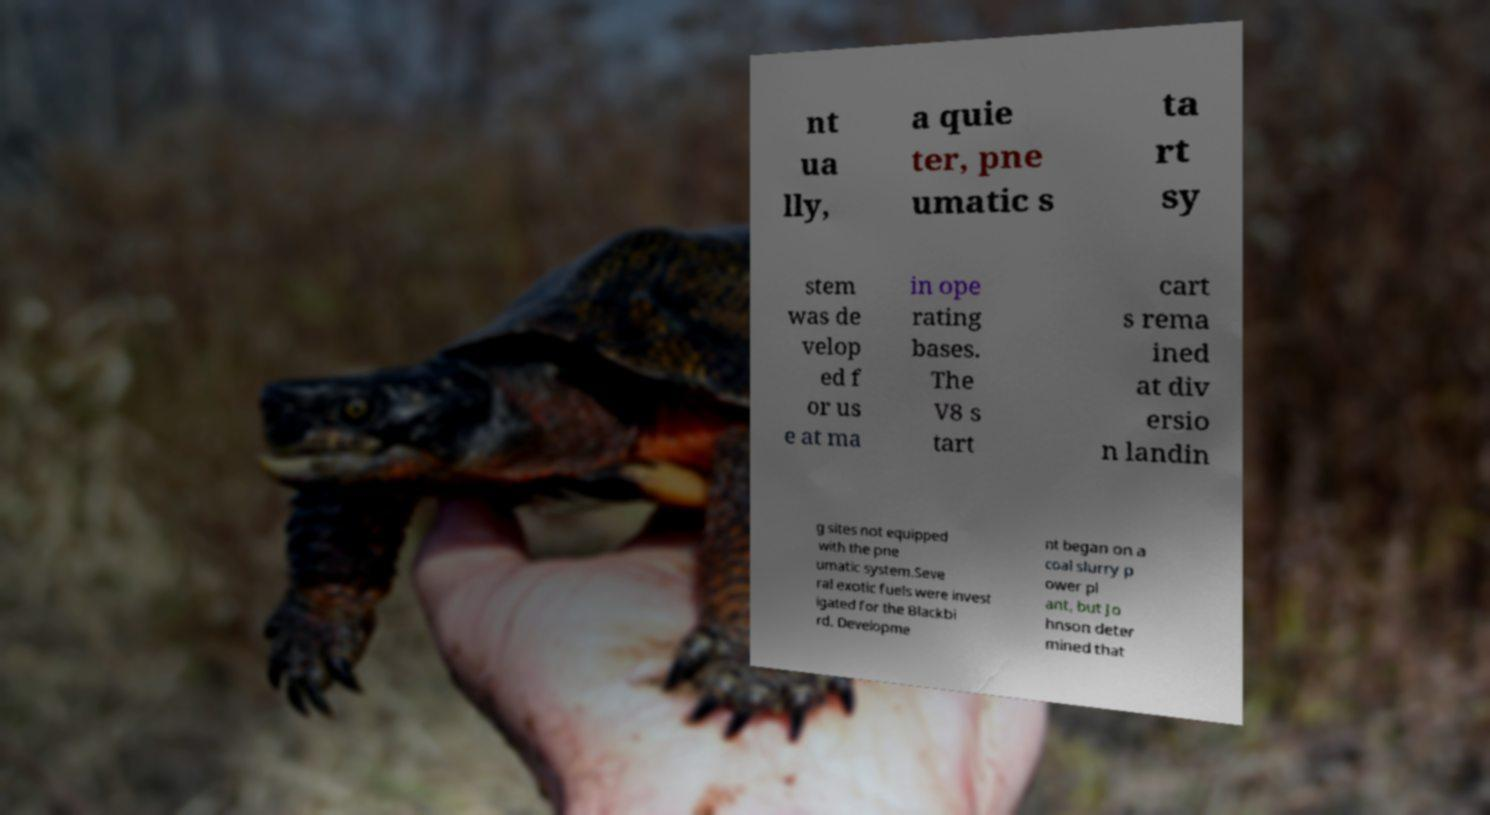Could you extract and type out the text from this image? nt ua lly, a quie ter, pne umatic s ta rt sy stem was de velop ed f or us e at ma in ope rating bases. The V8 s tart cart s rema ined at div ersio n landin g sites not equipped with the pne umatic system.Seve ral exotic fuels were invest igated for the Blackbi rd. Developme nt began on a coal slurry p ower pl ant, but Jo hnson deter mined that 